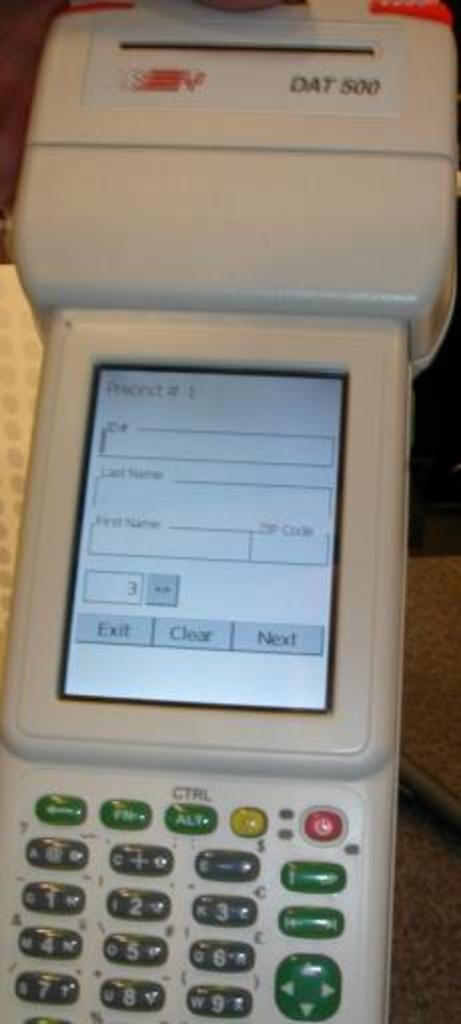Provide a one-sentence caption for the provided image. A DAT 500 machine device that contains many small buttons on the bottom below a small screen. 